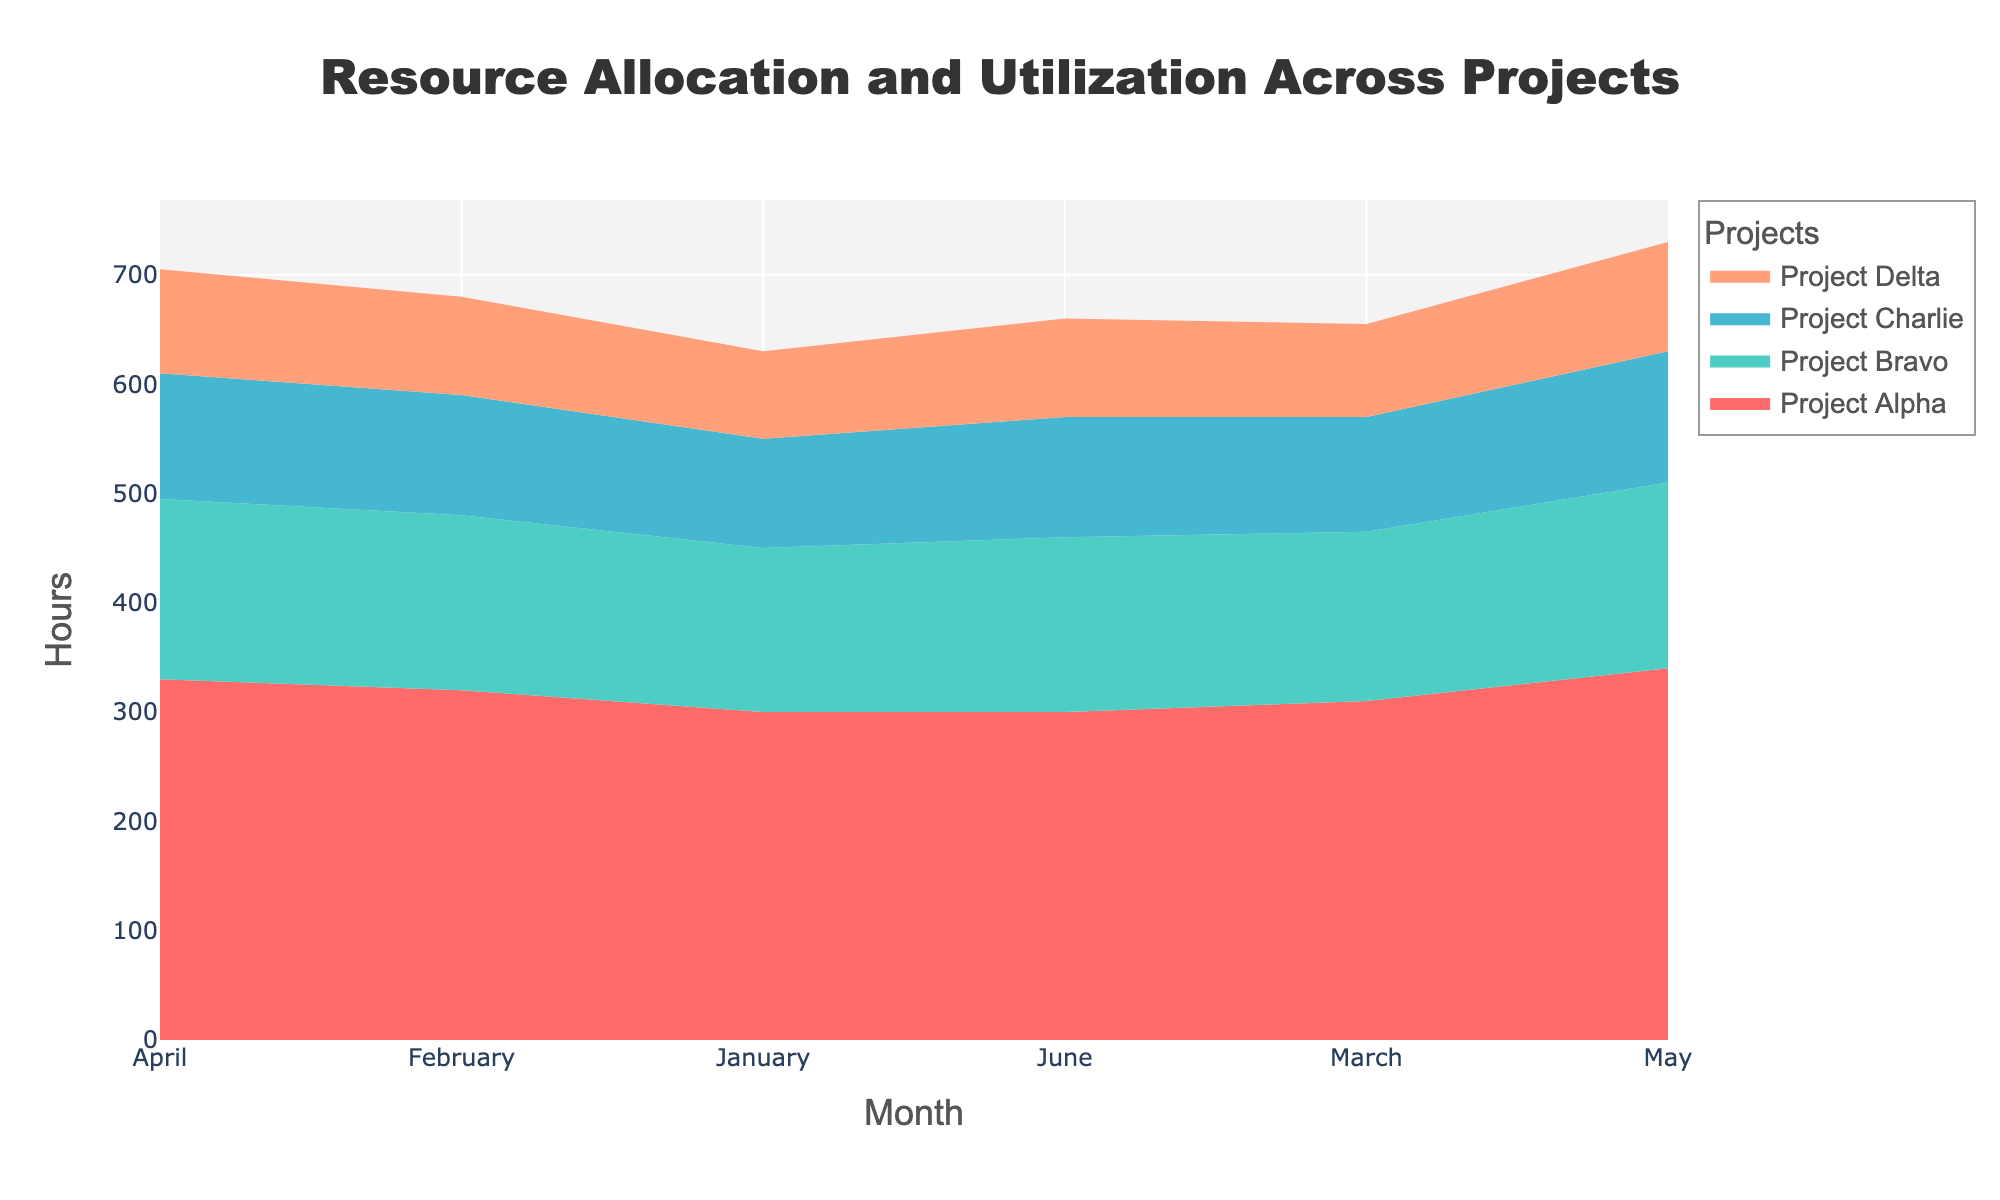What is the title of the figure? The title is located at the top of the figure and typically provides a summary of what the figure represents.
Answer: Resource Allocation and Utilization Across Projects Which months are displayed on the x-axis? The x-axis typically shows the range of time covered in the data. In this case, it lists months from January to June.
Answer: January, February, March, April, May, June Which project utilizes the most hours in May? By examining the heights of the colored areas for each project in May, we can see which has the tallest segment, indicating the most hours.
Answer: Project Alpha What is the total number of hours spent across all projects in February? To find this, sum up the heights of the colored segments for February across all projects. Project Alpha (320) + Project Bravo (160) + Project Charlie (110) + Project Delta (90) = 680
Answer: 680 Which project shows the least variation in resource allocation over the months? Look at the colored streams and identify the one with the flattest curve, indicating less variation over the months.
Answer: Project Delta Compare the resource allocation of the Development Team in March and April. Look at the heights of the Development Team's segment in March and April and compare them. March has 310 and April has 330, so April is higher.
Answer: April has more hours How do the resource allocations for Project Charlie change from January to June? Observe the height of the segments for Project Charlie from January to June to see the trend. Project Charlie increases slightly from 100 to 110.
Answer: Slight increase What is the combined resource allocation for Project Bravo and Project Delta in April? Add the hours allocated to Project Bravo and Project Delta in April. Project Bravo (165) + Project Delta (95) = 260 hours.
Answer: 260 During which month does Project Delta utilize the highest hours? By observing the height of Project Delta's colored stream, we can see it is highest in May.
Answer: May 